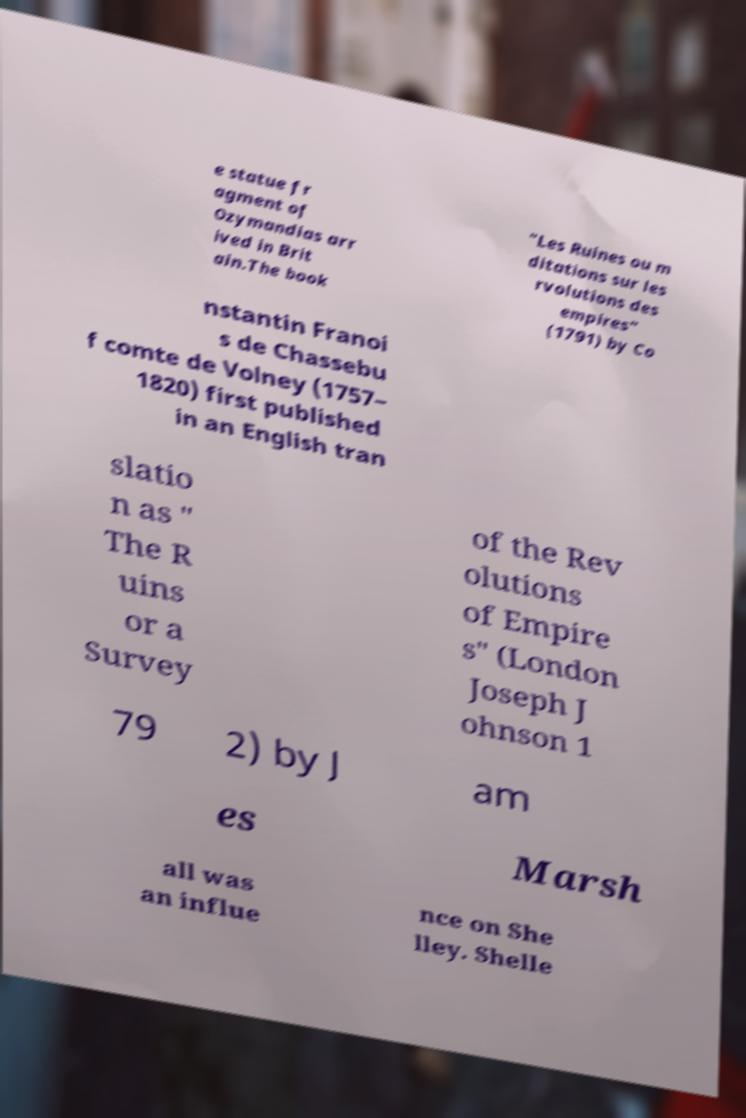What messages or text are displayed in this image? I need them in a readable, typed format. e statue fr agment of Ozymandias arr ived in Brit ain.The book "Les Ruines ou m ditations sur les rvolutions des empires" (1791) by Co nstantin Franoi s de Chassebu f comte de Volney (1757– 1820) first published in an English tran slatio n as " The R uins or a Survey of the Rev olutions of Empire s" (London Joseph J ohnson 1 79 2) by J am es Marsh all was an influe nce on She lley. Shelle 